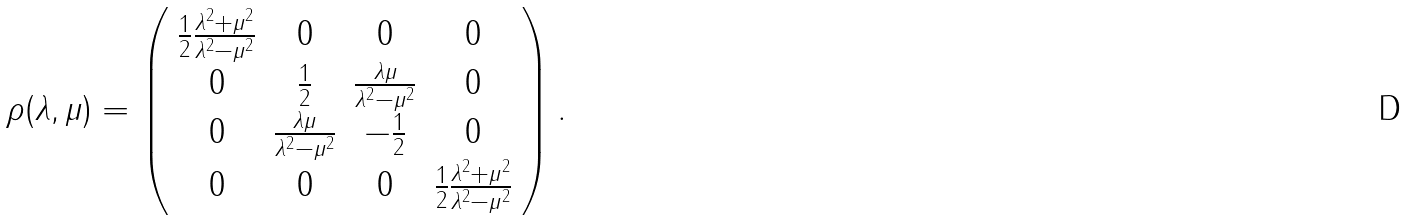<formula> <loc_0><loc_0><loc_500><loc_500>\rho ( \lambda , \mu ) = \left ( \begin{array} { c c c c } \frac { 1 } { 2 } \frac { \lambda ^ { 2 } + \mu ^ { 2 } } { \lambda ^ { 2 } - \mu ^ { 2 } } & 0 & 0 & 0 \\ 0 & \frac { 1 } { 2 } & \frac { \lambda \mu } { \lambda ^ { 2 } - \mu ^ { 2 } } & 0 \\ 0 & \frac { \lambda \mu } { \lambda ^ { 2 } - \mu ^ { 2 } } & - \frac { 1 } { 2 } & 0 \\ 0 & 0 & 0 & \frac { 1 } { 2 } \frac { \lambda ^ { 2 } + \mu ^ { 2 } } { \lambda ^ { 2 } - \mu ^ { 2 } } \end{array} \right ) .</formula> 